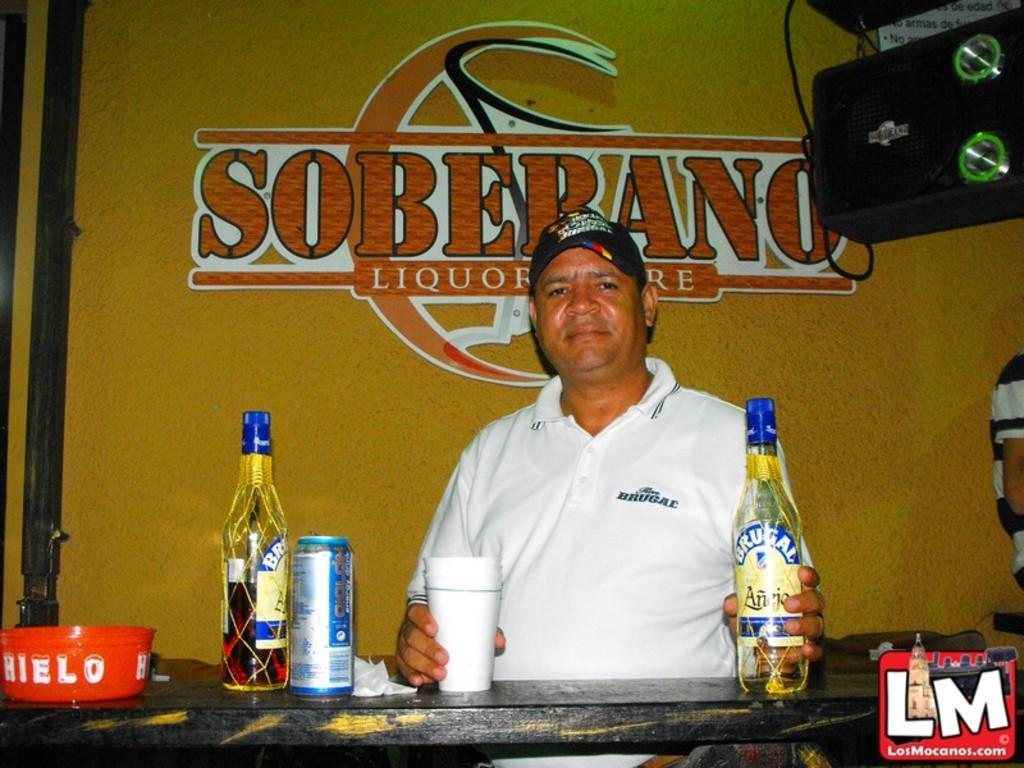<image>
Offer a succinct explanation of the picture presented. a partender holding a bottle of Brugal at the bar 